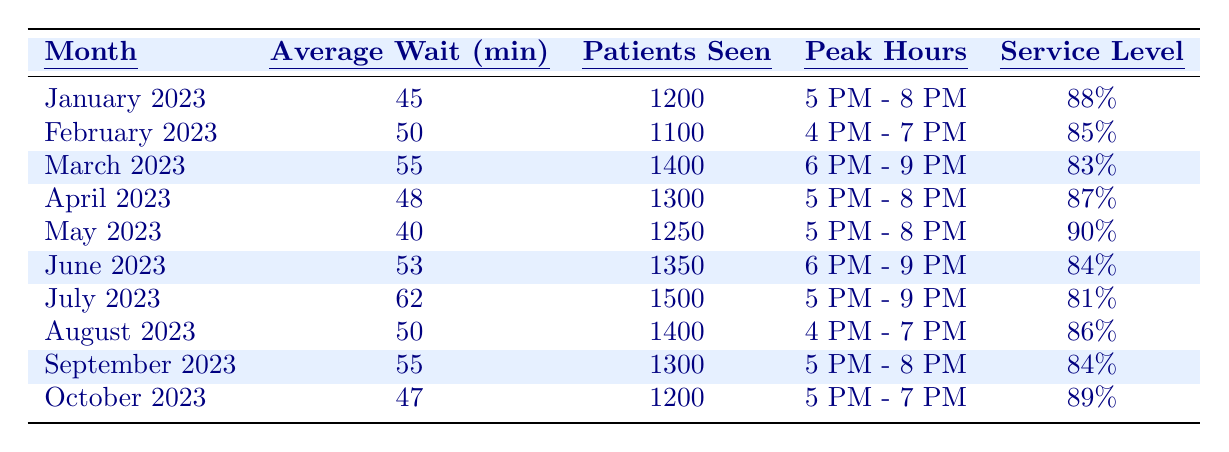What was the average wait time in May 2023? The table shows that the average wait time for May 2023 is listed under the "Average Wait (min)" column as 40 minutes.
Answer: 40 minutes Which month had the highest number of patients seen? According to the table, July 2023 had the highest number of patients seen, totaling 1500.
Answer: July 2023 What was the service level percentage in March 2023? The table indicates that the service level percentage for March 2023 is 83%, which is shown under the "Service Level" column.
Answer: 83% How does the average wait time in April 2023 compare to that in February 2023? The average wait time in April 2023 was 48 minutes, which is lower than the average wait time in February 2023, which was 50 minutes.
Answer: April had a shorter wait time What is the total number of patients seen from January to April 2023? To find the total number of patients, sum the "Patients Seen" for each month from January to April: 1200 + 1100 + 1400 + 1300 = 5000 patients.Total patients seen from January to April is 5000.
Answer: 5000 Is it true that the average wait time in June 2023 was higher than that in January 2023? The average wait time in June 2023 was 53 minutes, which is indeed higher than January's average wait time of 45 minutes. Thus, the statement is true.
Answer: Yes What was the change in the average wait times between May and July 2023? The average wait time in May 2023 was 40 minutes, while in July 2023, it increased to 62 minutes, resulting in a change of 62 - 40 = 22 minutes.
Answer: Increased by 22 minutes Which month or months had a service level below 85%? Referring to the table, the months with service levels below 85% are March (83%) and July (81%).
Answer: March and July What month had peak hours of 5 PM to 8 PM? According to the table, both January 2023 and April 2023 had peak hours listed as 5 PM to 8 PM.
Answer: January and April If the average wait time continues to rise similar to the increase from April to June (5 minutes), what would be the expected average wait time for July 2023? The average wait time increased from April (48 minutes) to June (53 minutes), resulting in a rise of 5 minutes. If this trend continues, adding another 5 minutes to June's average of 53 minutes would suggest an expected average wait time of 58 minutes for July.
Answer: 58 minutes (expected) 